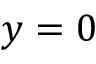Convert formula to latex. <formula><loc_0><loc_0><loc_500><loc_500>y = 0</formula> 